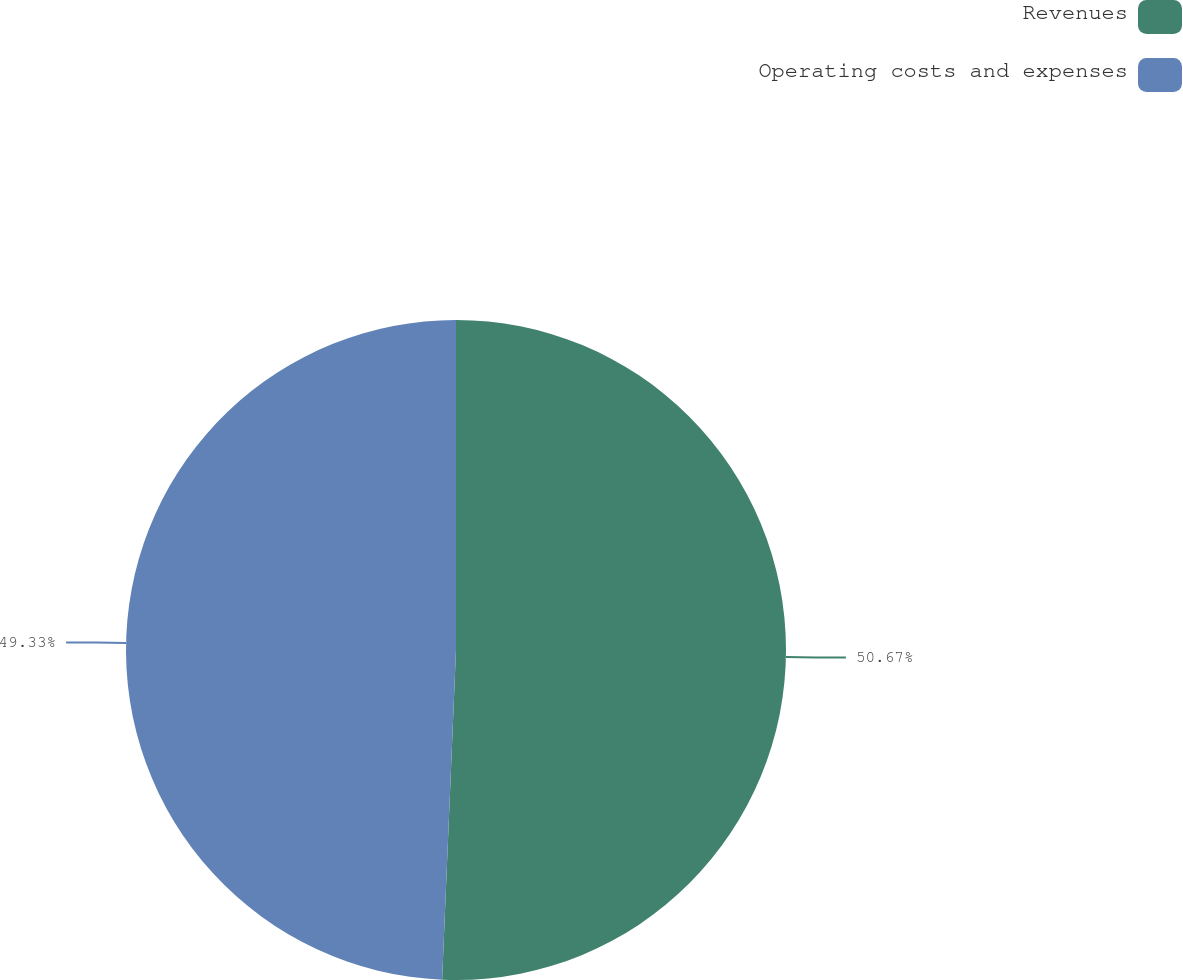<chart> <loc_0><loc_0><loc_500><loc_500><pie_chart><fcel>Revenues<fcel>Operating costs and expenses<nl><fcel>50.67%<fcel>49.33%<nl></chart> 